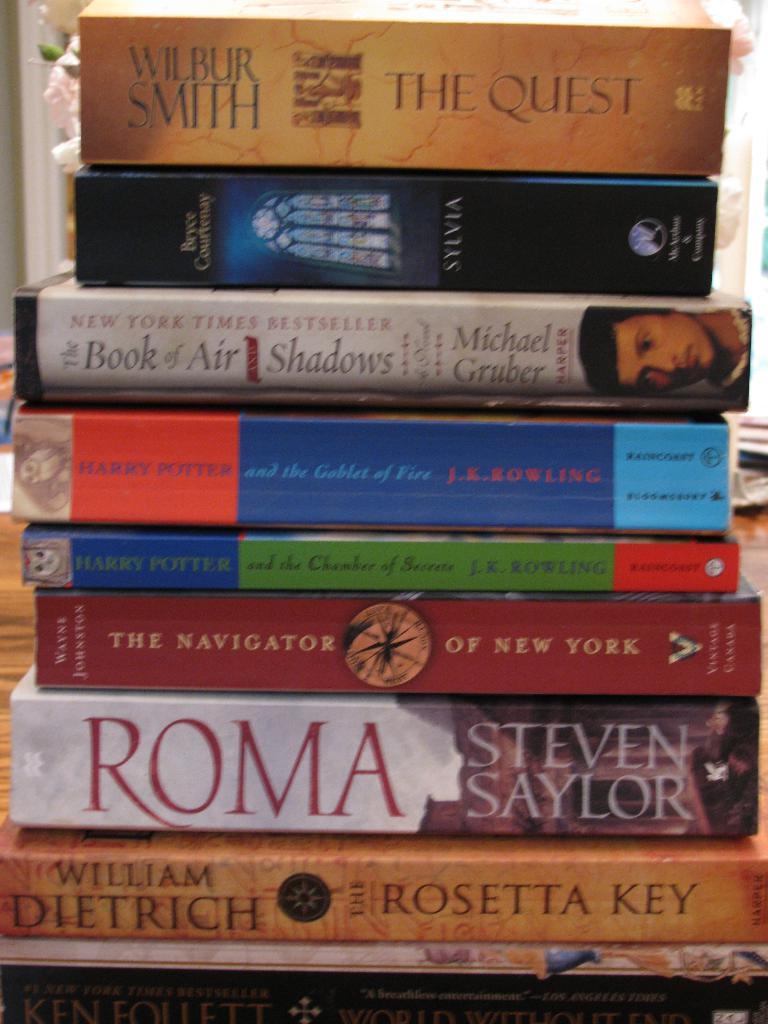What's the name of the first book?
Provide a short and direct response. The quest. What is the name of the author of the first book?
Offer a terse response. Wilbur smith. 